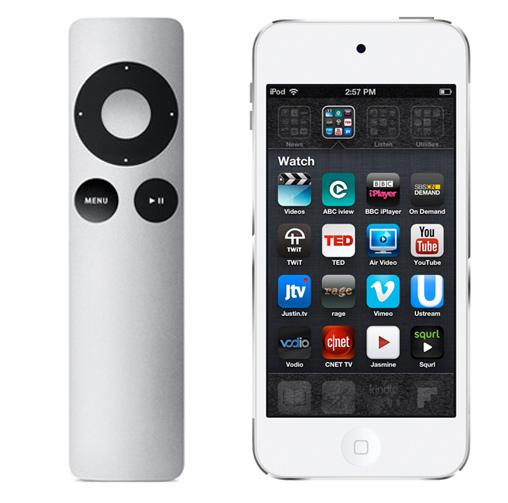Is this an iPod?
Answer briefly. Yes. What time is listed?
Write a very short answer. 2:57 pm. Which way is the red arrow pointing?
Be succinct. Right. 